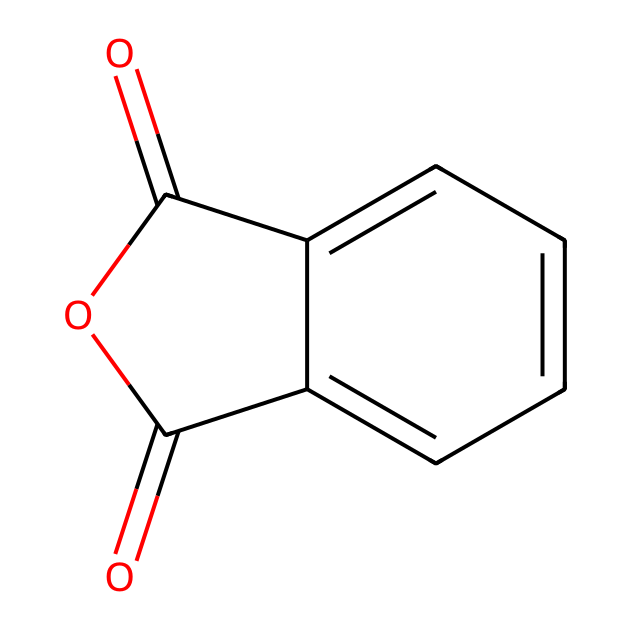What is the molecular formula of phthalic anhydride? To determine the molecular formula, we analyze the SMILES representation. The structure contains 8 carbon atoms (C), 4 oxygen atoms (O), and 4 hydrogen atoms (H), resulting in the formula C8H4O3.
Answer: C8H4O3 How many rings are present in the structure? By examining the SMILES representation, we see that there are two cyclic structures (rings) indicated by the presence of "C1" and "1" in the SMILES which indicates a cycle closure.
Answer: 2 What type of functional groups are present in phthalic anhydride? The structure contains an anhydride functional group (indicated by the carbonyl and cyclic ether) as well as aromatic rings (due to the benzene-like structure) clearly evident in the SMILES.
Answer: anhydride and aromatic Is phthalic anhydride soluble in water? Phthalic anhydride is known to have limited solubility in water, mainly due to its aromatic structure and the presence of hydrophobic regions in the molecule.
Answer: limited solubility How many carbonyl groups does phthalic anhydride have? Analyzing the structure through the SMILES shows that there are two carbonyl groups (C=O) present, one in each anhydride part of the molecule.
Answer: 2 What is the primary use of phthalic anhydride in the food industry? Phthalic anhydride is primarily used as a precursor for eco-friendly food dyes due to its ability to react and form dyes that meet sustainability criteria.
Answer: food dyes What makes phthalic anhydride an acid anhydride? The presence of the anhydride functional group, characterized by two carbonyl groups and a bridging oxygen that arises from the condensation of two carboxylic acids, classifies it as an acid anhydride.
Answer: two carbonyls and bridging oxygen 